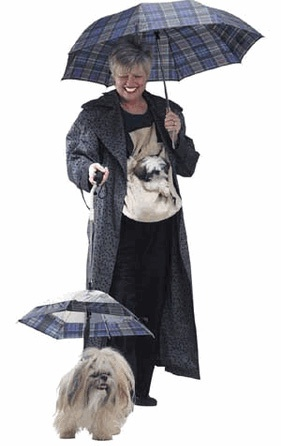Describe the objects in this image and their specific colors. I can see people in white, black, gray, darkgray, and lightgray tones, umbrella in white, gray, black, and darkgray tones, dog in white, darkgray, and gray tones, umbrella in white, gray, darkgray, and lightgray tones, and dog in white, lightgray, darkgray, gray, and black tones in this image. 